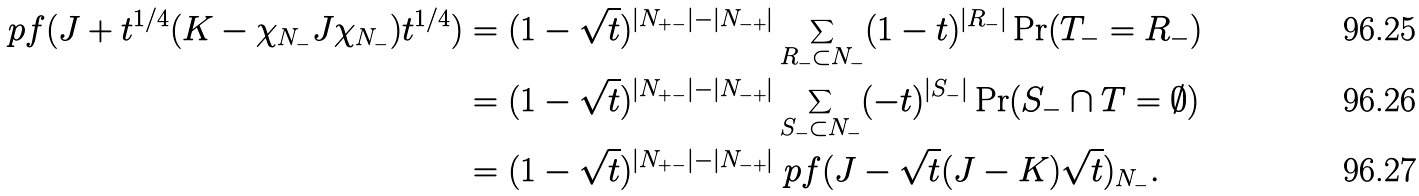<formula> <loc_0><loc_0><loc_500><loc_500>\ p f ( J + t ^ { 1 / 4 } ( K - \chi _ { N _ { - } } J \chi _ { N _ { - } } ) t ^ { 1 / 4 } ) & = ( 1 - \sqrt { t } ) ^ { | N _ { + - } | - | N _ { - + } | } \sum _ { R _ { - } \subset N _ { - } } ( 1 - t ) ^ { | R _ { - } | } \Pr ( T _ { - } = R _ { - } ) \\ & = ( 1 - \sqrt { t } ) ^ { | N _ { + - } | - | N _ { - + } | } \sum _ { S _ { - } \subset N _ { - } } ( - t ) ^ { | S _ { - } | } \Pr ( S _ { - } \cap T = \emptyset ) \\ & = ( 1 - \sqrt { t } ) ^ { | N _ { + - } | - | N _ { - + } | } \ p f ( J - \sqrt { t } ( J - K ) \sqrt { t } ) _ { N _ { - } } .</formula> 